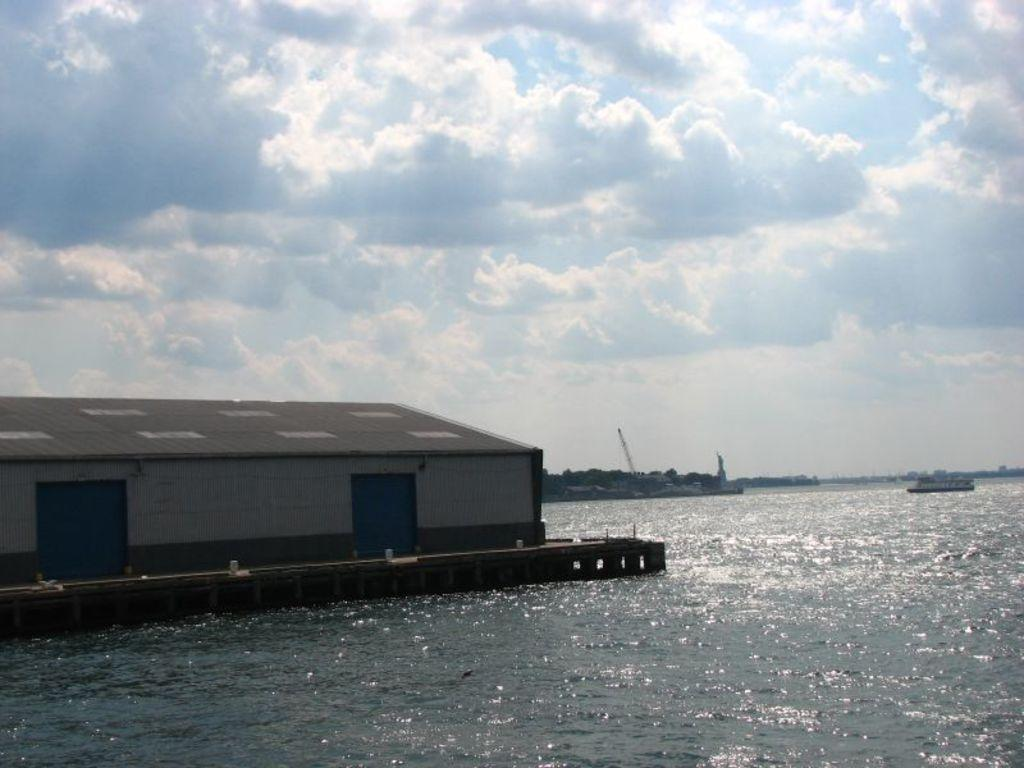What type of structure is located on the water in the image? There is a house on the water in the image. What can be seen in the background of the image? There are boats visible in the background of the image. What colors are present in the sky in the image? The sky is blue and white in color. Where is the rabbit hiding in the image? There is no rabbit present in the image. What type of sheet is covering the house on the water? There is no sheet covering the house on the water in the image. 